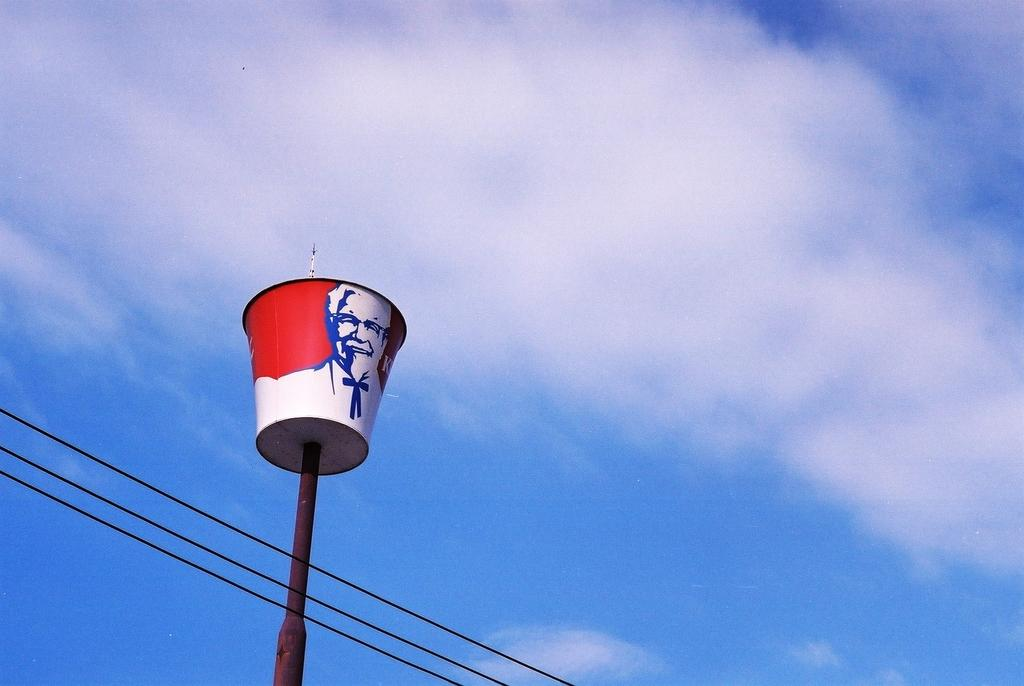What type of food container is visible in the image? There is a KFC bucket in the image. Where is the KFC bucket located in relation to other objects? The KFC bucket is near a pole. What else can be seen in the image besides the KFC bucket? There are cables in the image. What can be seen in the background of the image? The sky is visible in the background of the image. How much money is on the calculator in the image? There is no calculator or money present in the image. What type of deer can be seen grazing near the KFC bucket in the image? There are no deer present in the image; it only features a KFC bucket, a pole, cables, and the sky in the background. 